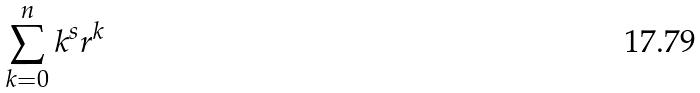<formula> <loc_0><loc_0><loc_500><loc_500>\sum _ { k = 0 } ^ { n } k ^ { s } r ^ { k }</formula> 